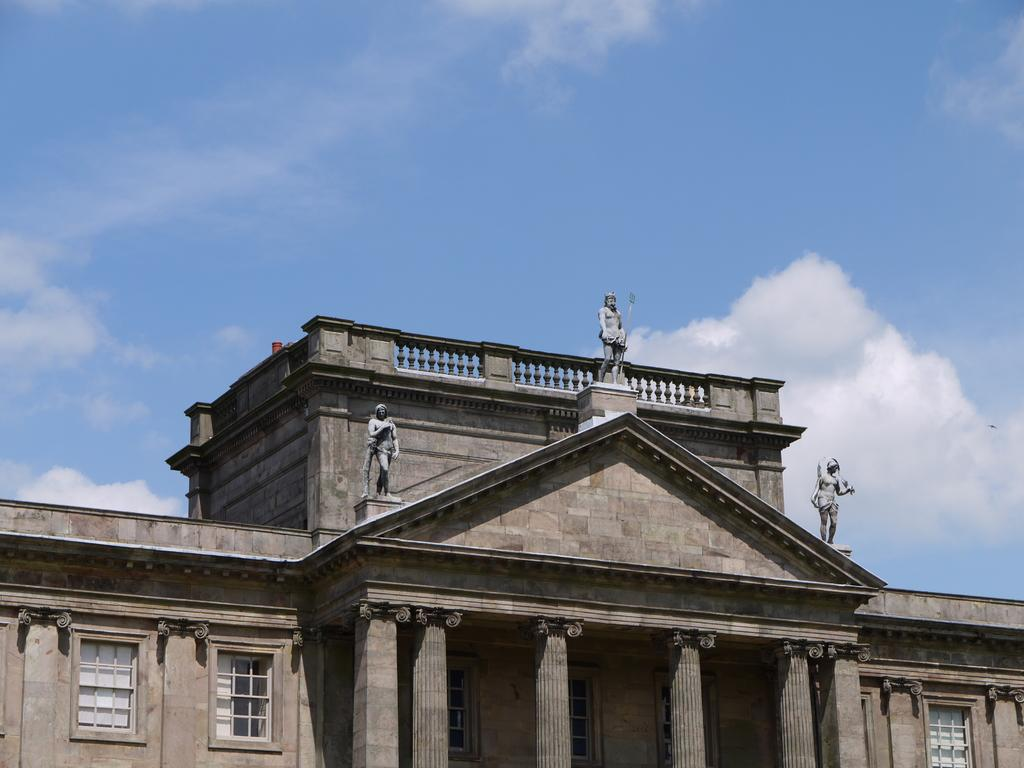What type of structure is visible in the image? There is a building in the image. What can be seen in the middle of the image? There are statues in the middle of the image. What is visible at the top of the image? The sky is visible at the top of the image. How many ladybugs are sitting on the statues in the image? There are no ladybugs present in the image; it only features statues and a building. Is the queen present in the image? There is no mention of a queen or any royal figure in the image. 